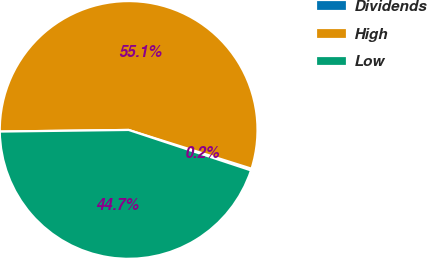Convert chart to OTSL. <chart><loc_0><loc_0><loc_500><loc_500><pie_chart><fcel>Dividends<fcel>High<fcel>Low<nl><fcel>0.22%<fcel>55.06%<fcel>44.72%<nl></chart> 